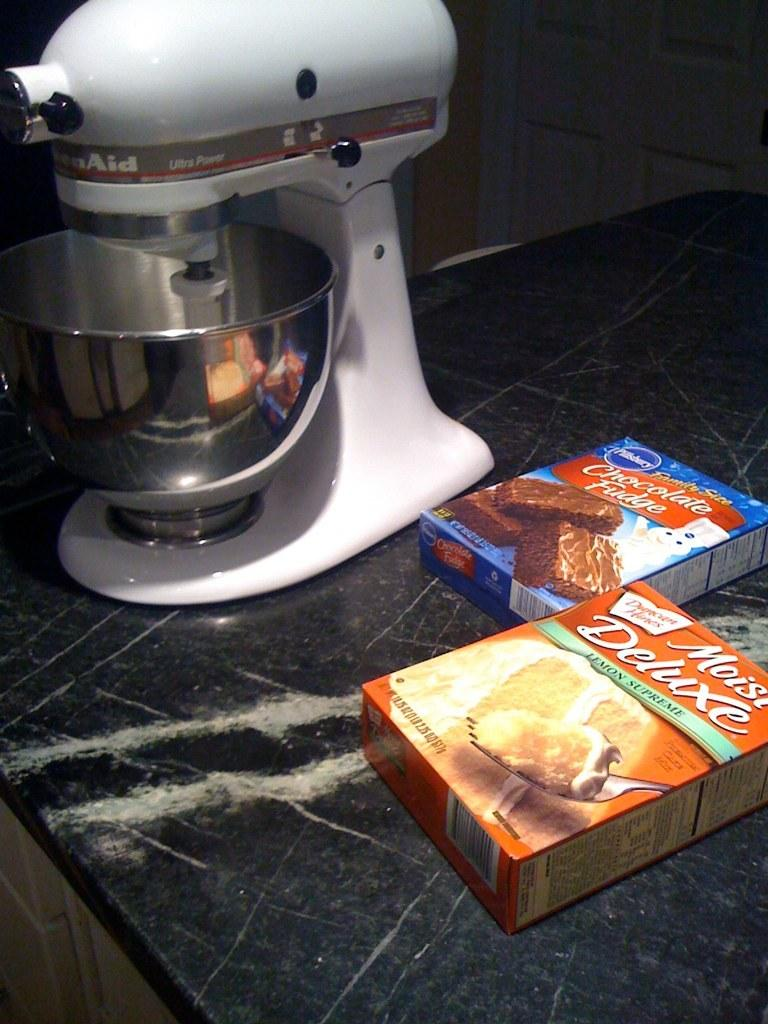Provide a one-sentence caption for the provided image. Two boxes of Pillsburry cake batter on a counter next to a Kitchen Aid mixer. 